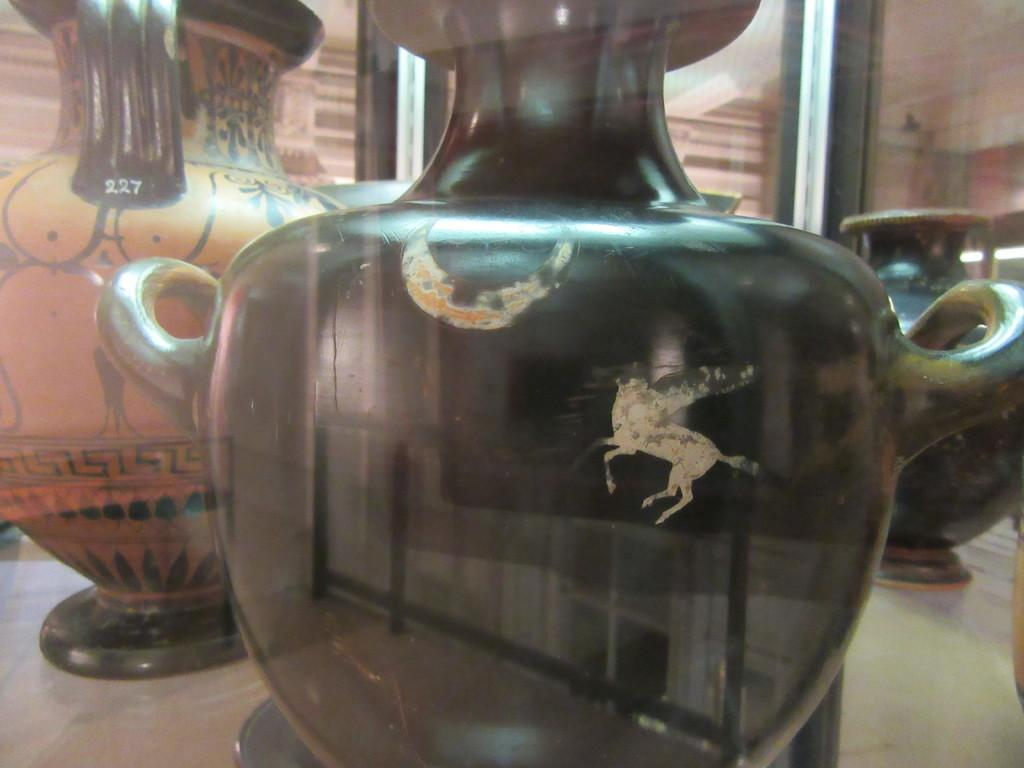What objects are present on the surface in the image? There are flower vases on a surface in the image. What might be the purpose of these objects? The flower vases are likely used for holding and displaying flowers. Can you describe the surface on which the flower vases are placed? The provided facts do not give information about the surface, so it cannot be described. How many boys are holding rings while standing on the ice in the image? There are no boys, rings, or ice present in the image; it only features flower vases on a surface. 